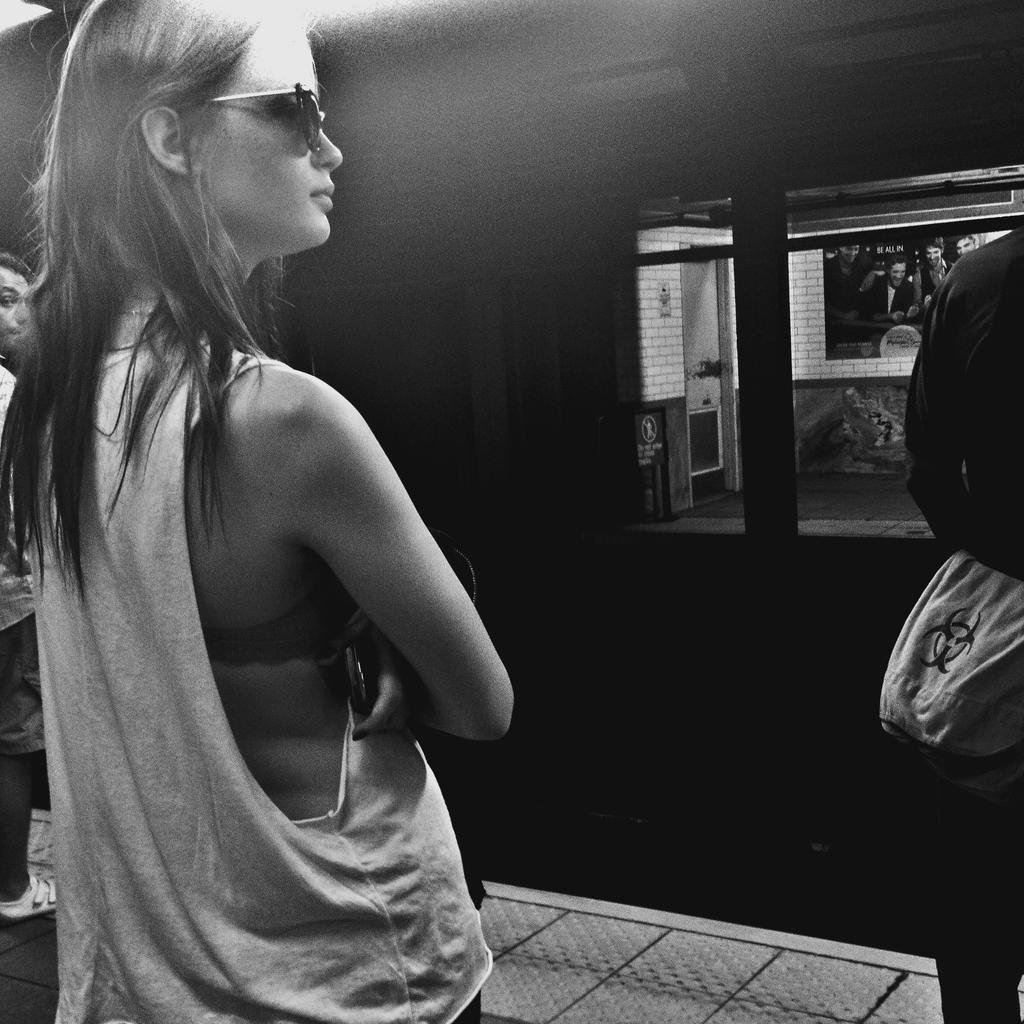Please provide a concise description of this image. In the middle of the image few people are standing. In front of them we can see a locomotive. 